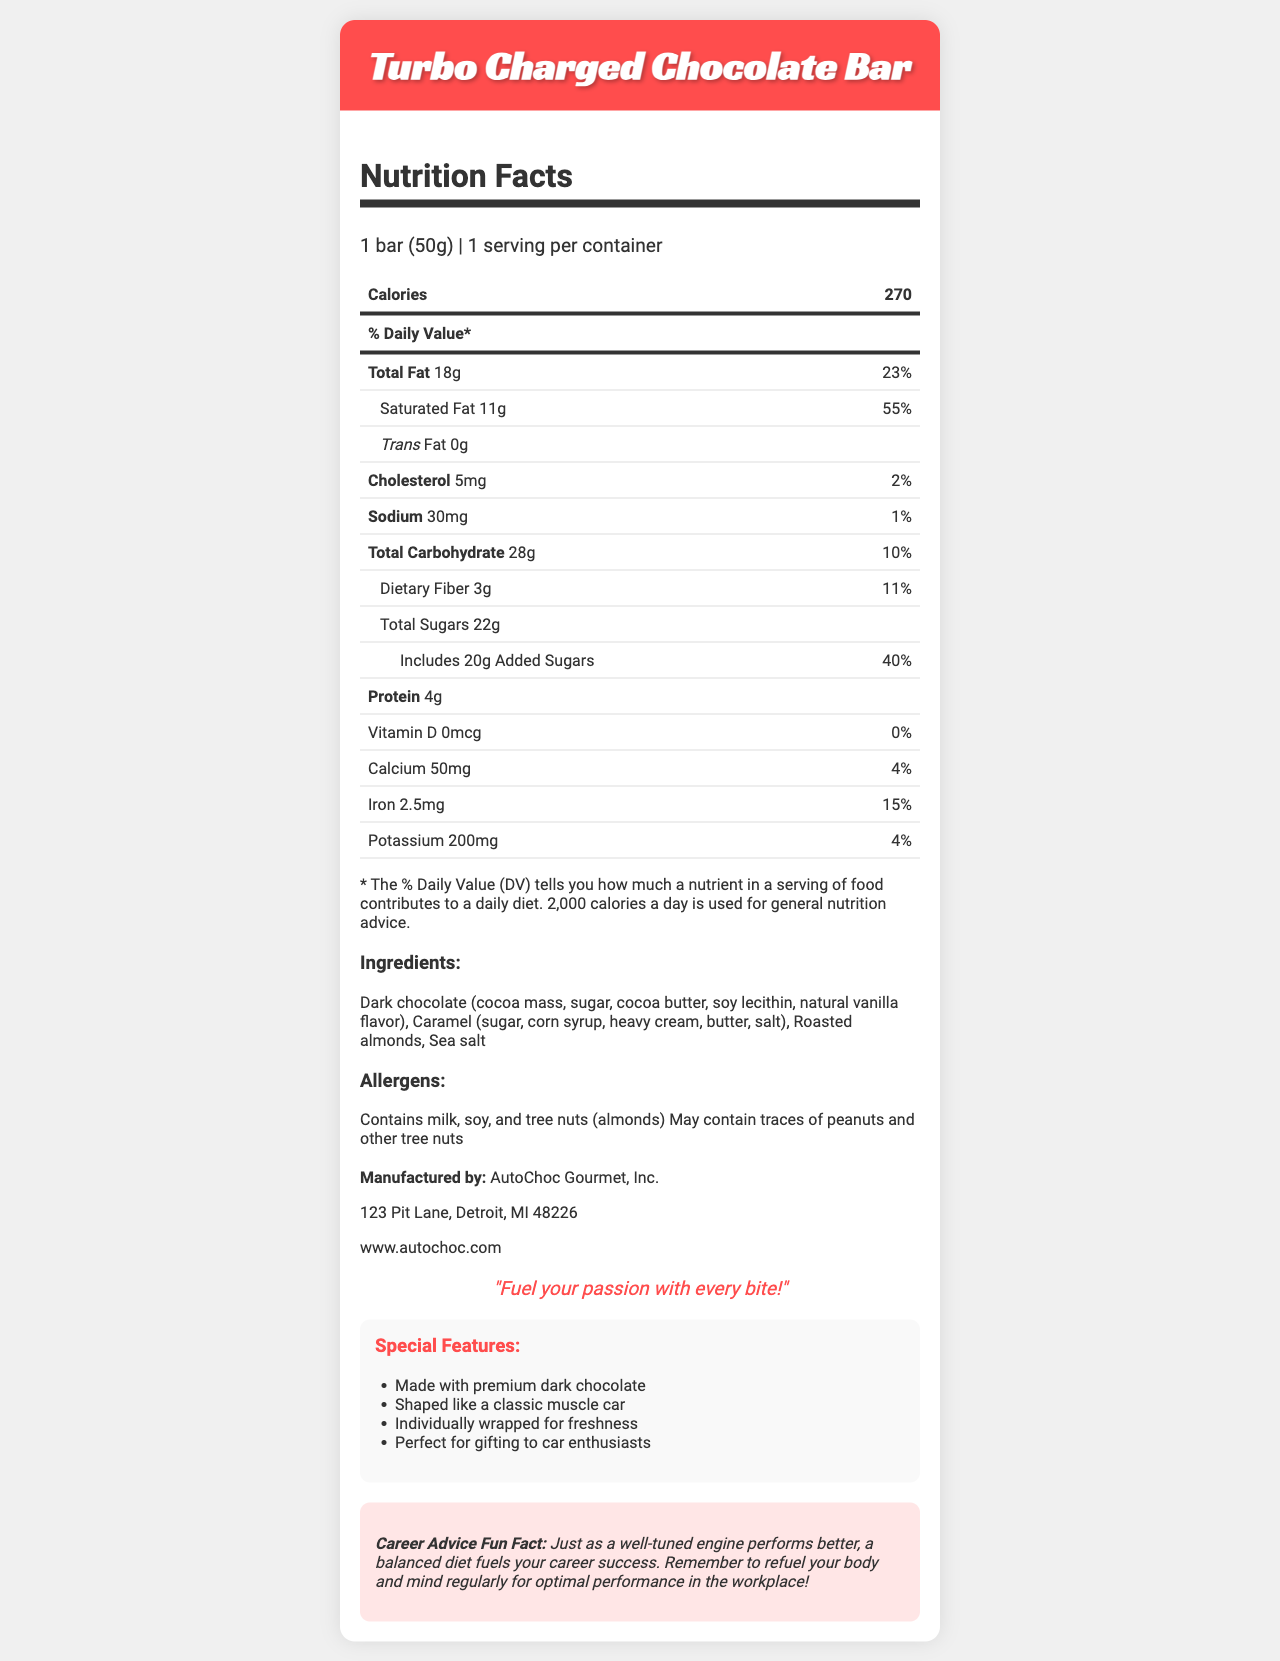how many calories are in one serving of the Turbo Charged Chocolate Bar? The document states that one serving of the Turbo Charged Chocolate Bar contains 270 calories.
Answer: 270 what is the serving size for the Turbo Charged Chocolate Bar? The document specifies that the serving size is 1 bar (50g).
Answer: 1 bar (50g) what percentage of Daily Value is the saturated fat content of the chocolate bar? The document shows that the saturated fat content is 11g, which corresponds to 55% of the Daily Value.
Answer: 55% how much protein does the Turbo Charged Chocolate Bar contain? The document lists the protein content as 4g.
Answer: 4g list the allergens contained in the Turbo Charged Chocolate Bar. The allergens section of the document provides this information.
Answer: Contains milk, soy, and tree nuts (almonds). May contain traces of peanuts and other tree nuts. which company manufactures the Turbo Charged Chocolate Bar? A. ChocoCar Delights B. AutoChoc Gourmet, Inc. C. Speedy Sweets The document lists AutoChoc Gourmet, Inc. as the manufacturer.
Answer: B how much dietary fiber is in the Turbo Charged Chocolate Bar? The dietary fiber content is listed as 3g in the document.
Answer: 3g what is the website mentioned in the document for more information? The document lists the website as www.autochoc.com.
Answer: www.autochoc.com how much of the Total Sugars are added sugars? The document indicates that out of the 22g of total sugars, 20g are added sugars.
Answer: 20g does the Turbo Charged Chocolate Bar contain any trans fat? Yes/No The document explicitly states that the trans fat content is 0g.
Answer: No what should you keep in mind about refueling your body according to the fun fact? The fun fact section mentions that a balanced diet is important for career success, similar to tuning an engine for better performance.
Answer: Refuel your body and mind regularly for optimal performance in the workplace. what are some special features of the Turbo Charged Chocolate Bar? These features are listed under the "Special Features" section in the document.
Answer: Made with premium dark chocolate, Shaped like a classic muscle car, Individually wrapped for freshness, Perfect for gifting to car enthusiasts does the Turbo Charged Chocolate Bar contain Vitamin D? The document shows that the Vitamin D content is 0mcg, accounting for 0% DV.
Answer: No what is the main theme or idea of the Turbo Charged Chocolate Bar’s packaging? The document presents the product as a car-themed chocolate bar aimed at car enthusiasts, featuring premium ingredients, special nutritional facts, and a unique muscle car shape.
Answer: The Turbo Charged Chocolate Bar has a car-themed design tailored for auto enthusiasts, with a focus on gourmet ingredients and nutritional information. how many total grams of carbohydrates are in one serving? The Total Carbohydrate content is listed as 28g in the document.
Answer: 28g what is the exact address of the manufacturer? The manufacturer's address is provided in the document.
Answer: 123 Pit Lane, Detroit, MI 48226 what are the ingredients of the Turbo Charged Chocolate Bar? The list of ingredients is detailed in the document.
Answer: Dark chocolate (cocoa mass, sugar, cocoa butter, soy lecithin, natural vanilla flavor), Caramel (sugar, corn syrup, heavy cream, butter, salt), Roasted almonds, Sea salt how much calcium does the Turbo Charged Chocolate Bar provide? A. 25mg B. 50mg C. 100mg D. 0mg The document indicates that the chocolate bar contains 50mg of calcium.
Answer: B who is the target audience for the Turbo Charged Chocolate Bar? The document highlights that the chocolate bar is perfect for gifting to car enthusiasts, implying they are the target audience.
Answer: Car enthusiasts when was AutoChoc Gourmet, Inc. founded? The document does not provide any details about the founding date of AutoChoc Gourmet, Inc.
Answer: Not enough information 